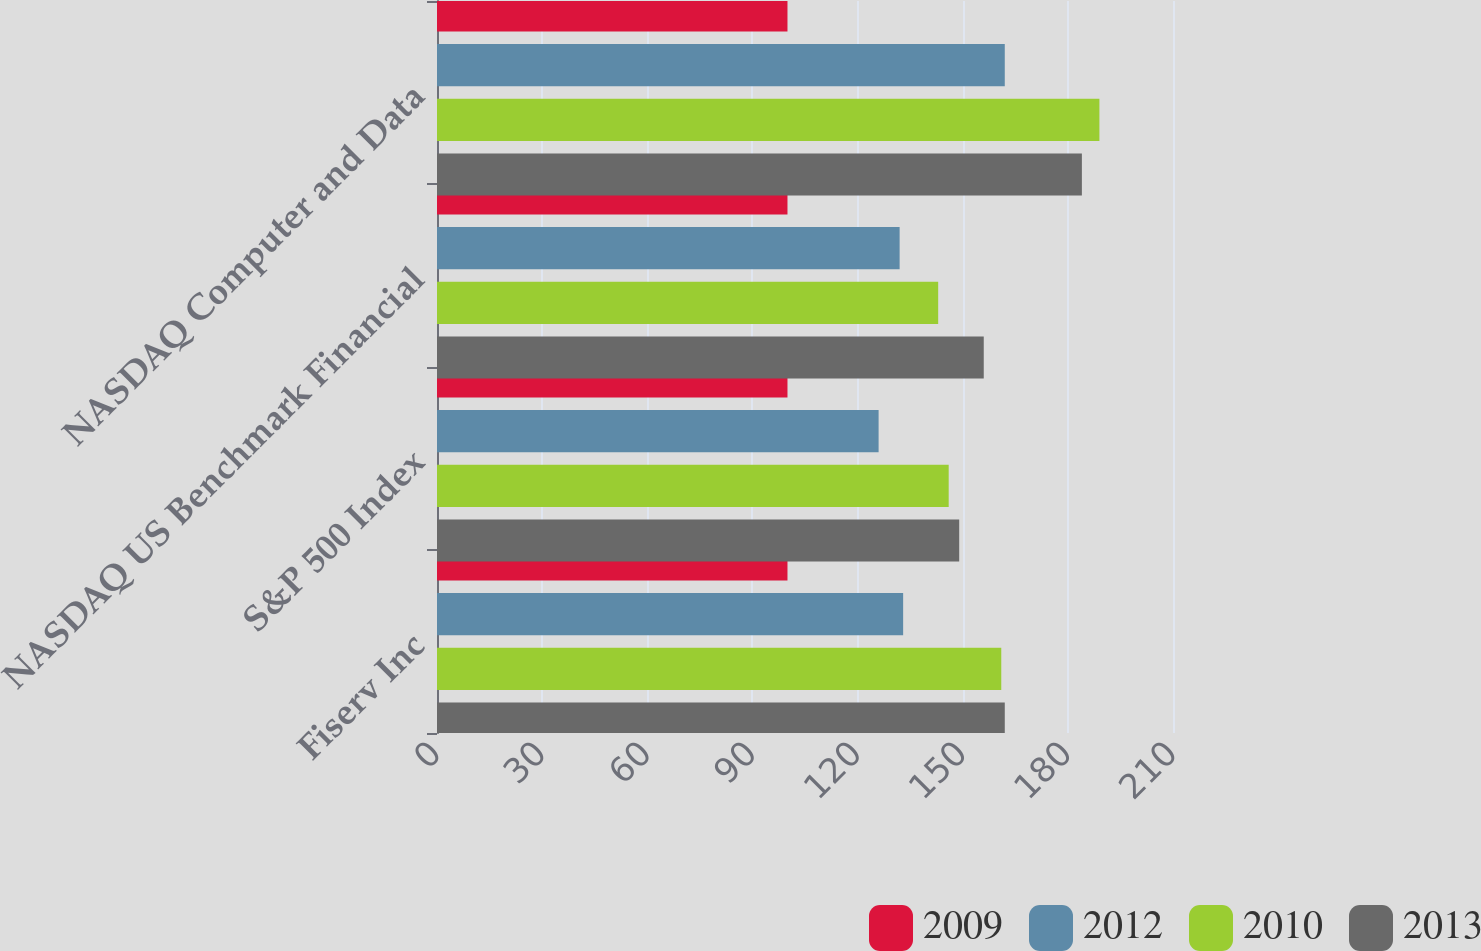Convert chart to OTSL. <chart><loc_0><loc_0><loc_500><loc_500><stacked_bar_chart><ecel><fcel>Fiserv Inc<fcel>S&P 500 Index<fcel>NASDAQ US Benchmark Financial<fcel>NASDAQ Computer and Data<nl><fcel>2009<fcel>100<fcel>100<fcel>100<fcel>100<nl><fcel>2012<fcel>133<fcel>126<fcel>132<fcel>162<nl><fcel>2010<fcel>161<fcel>146<fcel>143<fcel>189<nl><fcel>2013<fcel>162<fcel>149<fcel>156<fcel>184<nl></chart> 